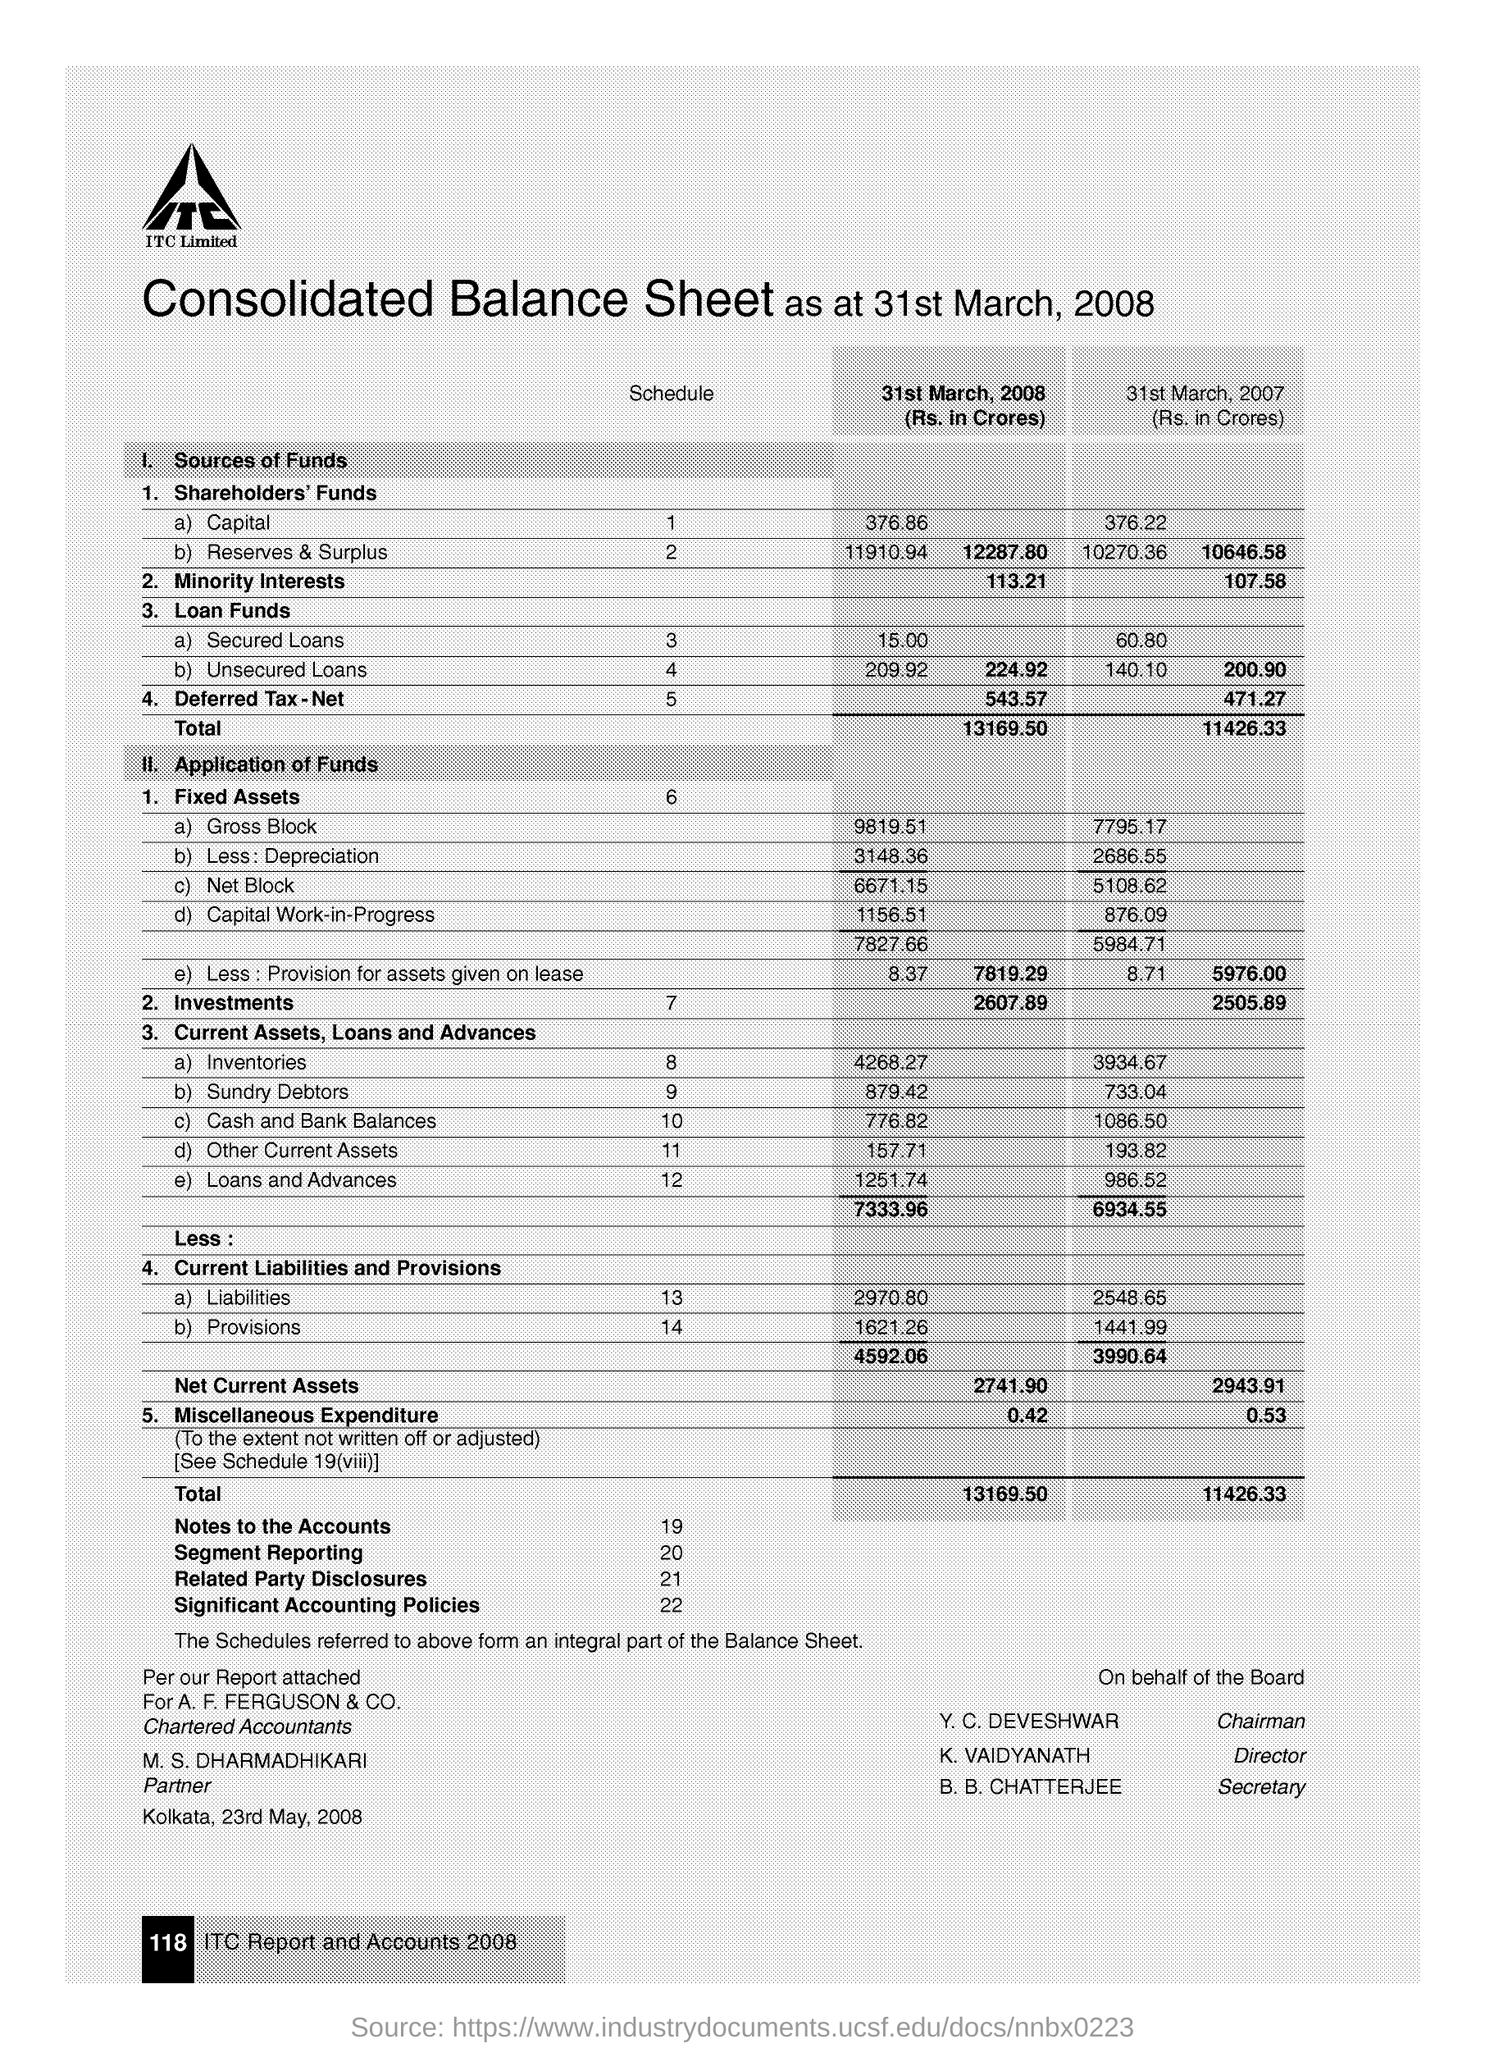When is the document dated on?
Your response must be concise. 23rd May, 2008. What is the place name on the document?
Give a very brief answer. Kolkata. What is the Investments for 31st March, 2008?
Make the answer very short. 2607.89. What is the Investments for 31st March, 2007?
Offer a very short reply. 2505.89. Who is the Director?
Keep it short and to the point. K. Vaidyanath. Who is the Chairman?
Offer a very short reply. Y. C. Deveshwar. Who is the Secretary?
Your answer should be compact. B. B. Chatterjee. Who is the Partner?
Offer a very short reply. M. S. Dharmadhikari. 